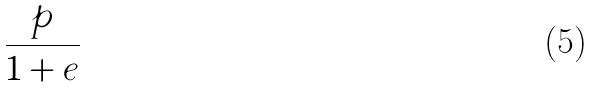<formula> <loc_0><loc_0><loc_500><loc_500>\frac { p } { 1 + e }</formula> 